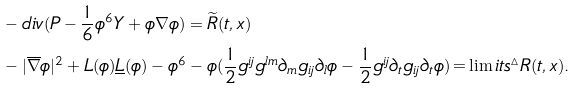Convert formula to latex. <formula><loc_0><loc_0><loc_500><loc_500>& - d i v ( P - \frac { 1 } { 6 } \phi ^ { 6 } Y + \phi \nabla \phi ) = \widetilde { R } ( t , x ) \\ & - | \overline { \nabla } \phi | ^ { 2 } + L ( \phi ) \underline { L } ( \phi ) - \phi ^ { 6 } - \phi ( \frac { 1 } { 2 } g ^ { i j } g ^ { l m } \partial _ { m } g _ { i j } \partial _ { l } \phi - \frac { 1 } { 2 } g ^ { i j } \partial _ { t } g _ { i j } \partial _ { t } \phi ) \mathop = \lim i t s ^ { \vartriangle } R ( t , x ) . \\</formula> 